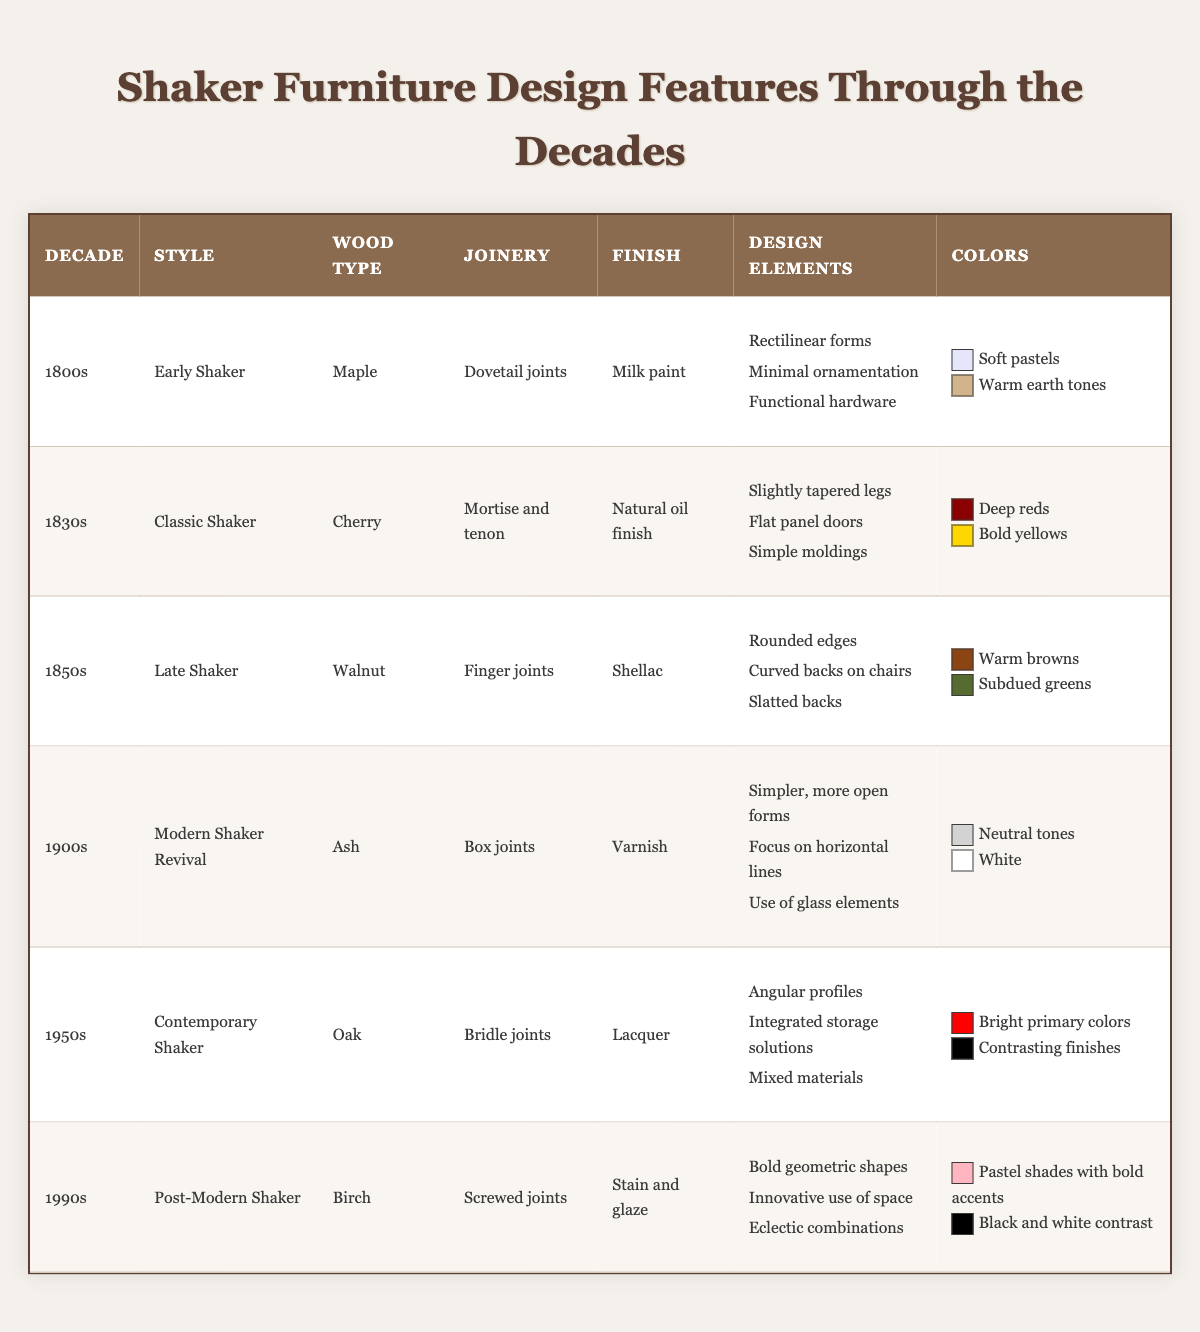What wood type was commonly used in Early Shaker furniture? The table specifies that the wood type for Early Shaker furniture is Maple, as listed in the respective row of the table.
Answer: Maple Which joinery technique was utilized for furniture in the 1830s? The table indicates that Mortise and tenon was the joinery technique used in the Classic Shaker style of the 1830s, found in the corresponding row.
Answer: Mortise and tenon Did the Late Shaker style feature angular profiles? By examining the table for the Late Shaker style, we can see that angular profiles are not listed under design elements, meaning this statement is false.
Answer: No What were the predominant colors used in furniture from the 1900s? The 1900s section of the table describes the colors used as neutral tones and white. Both colors are explicitly mentioned in that row.
Answer: Neutral tones, white Which decade featured furniture with rounded edges as a design element? The table shows that rounded edges were a design feature in the Late Shaker style from the 1850s, directly listed in that section.
Answer: 1850s How many different wood types are represented in the table? There are six unique wood types listed across the table (Maple, Cherry, Walnut, Ash, Oak, Birch), so we can count these distinct entries.
Answer: 6 What kind of finish was used for Contemporary Shaker furniture? The table states that a lacquer finish was used in the Contemporary Shaker style of the 1950s, visible in the respective row.
Answer: Lacquer Compare the design elements of Early Shaker and Late Shaker furniture. Early Shaker features rectilinear forms, minimal ornamentation, and functional hardware. In contrast, Late Shaker adds rounded edges, curved backs on chairs, and slatted backs, reflecting a shift towards more rounded forms.
Answer: Early: Rectilinear forms, Late: Rounded edges What is the difference in the finishes used between Classic Shaker and Post-Modern Shaker? Classic Shaker used a natural oil finish while Post-Modern Shaker employed stain and glaze, indicating a transition from natural to more elaborate finishes.
Answer: Classic: Natural oil, Post-Modern: Stain and glaze Which decade's furniture emphasizes innovative use of space, and which wood type was used for it? The table indicates that the 1990s (Post-Modern Shaker) emphasized innovative use of space and utilized birch as the wood type, combining these two details into the answer.
Answer: 1990s, Birch 